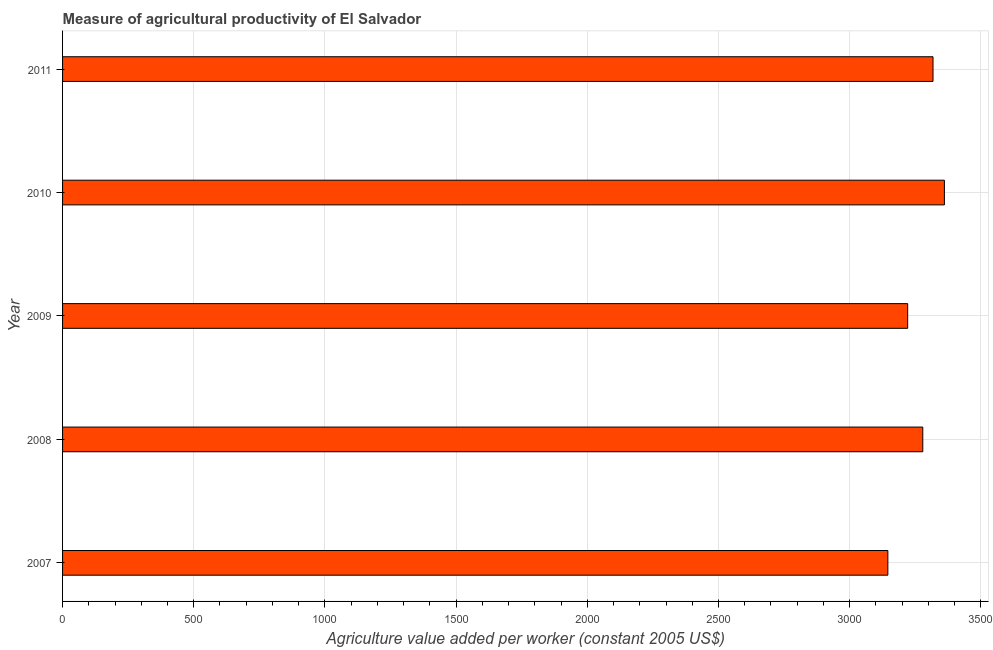What is the title of the graph?
Offer a terse response. Measure of agricultural productivity of El Salvador. What is the label or title of the X-axis?
Your answer should be compact. Agriculture value added per worker (constant 2005 US$). What is the agriculture value added per worker in 2010?
Provide a short and direct response. 3361.13. Across all years, what is the maximum agriculture value added per worker?
Provide a succinct answer. 3361.13. Across all years, what is the minimum agriculture value added per worker?
Your answer should be very brief. 3145.65. What is the sum of the agriculture value added per worker?
Make the answer very short. 1.63e+04. What is the difference between the agriculture value added per worker in 2007 and 2009?
Your response must be concise. -75.48. What is the average agriculture value added per worker per year?
Offer a very short reply. 3264.87. What is the median agriculture value added per worker?
Offer a very short reply. 3278.72. In how many years, is the agriculture value added per worker greater than 300 US$?
Provide a succinct answer. 5. Do a majority of the years between 2008 and 2007 (inclusive) have agriculture value added per worker greater than 300 US$?
Provide a succinct answer. No. What is the ratio of the agriculture value added per worker in 2009 to that in 2011?
Provide a succinct answer. 0.97. Is the agriculture value added per worker in 2010 less than that in 2011?
Ensure brevity in your answer.  No. Is the difference between the agriculture value added per worker in 2007 and 2008 greater than the difference between any two years?
Ensure brevity in your answer.  No. What is the difference between the highest and the second highest agriculture value added per worker?
Provide a succinct answer. 43.4. Is the sum of the agriculture value added per worker in 2007 and 2009 greater than the maximum agriculture value added per worker across all years?
Your answer should be very brief. Yes. What is the difference between the highest and the lowest agriculture value added per worker?
Give a very brief answer. 215.49. How many years are there in the graph?
Your response must be concise. 5. What is the difference between two consecutive major ticks on the X-axis?
Your answer should be very brief. 500. Are the values on the major ticks of X-axis written in scientific E-notation?
Your answer should be very brief. No. What is the Agriculture value added per worker (constant 2005 US$) of 2007?
Provide a short and direct response. 3145.65. What is the Agriculture value added per worker (constant 2005 US$) in 2008?
Ensure brevity in your answer.  3278.72. What is the Agriculture value added per worker (constant 2005 US$) in 2009?
Offer a very short reply. 3221.13. What is the Agriculture value added per worker (constant 2005 US$) in 2010?
Your response must be concise. 3361.13. What is the Agriculture value added per worker (constant 2005 US$) in 2011?
Provide a succinct answer. 3317.74. What is the difference between the Agriculture value added per worker (constant 2005 US$) in 2007 and 2008?
Offer a very short reply. -133.07. What is the difference between the Agriculture value added per worker (constant 2005 US$) in 2007 and 2009?
Your answer should be compact. -75.48. What is the difference between the Agriculture value added per worker (constant 2005 US$) in 2007 and 2010?
Keep it short and to the point. -215.49. What is the difference between the Agriculture value added per worker (constant 2005 US$) in 2007 and 2011?
Offer a very short reply. -172.09. What is the difference between the Agriculture value added per worker (constant 2005 US$) in 2008 and 2009?
Offer a very short reply. 57.59. What is the difference between the Agriculture value added per worker (constant 2005 US$) in 2008 and 2010?
Your response must be concise. -82.41. What is the difference between the Agriculture value added per worker (constant 2005 US$) in 2008 and 2011?
Your answer should be compact. -39.02. What is the difference between the Agriculture value added per worker (constant 2005 US$) in 2009 and 2010?
Ensure brevity in your answer.  -140.01. What is the difference between the Agriculture value added per worker (constant 2005 US$) in 2009 and 2011?
Your response must be concise. -96.61. What is the difference between the Agriculture value added per worker (constant 2005 US$) in 2010 and 2011?
Your answer should be very brief. 43.4. What is the ratio of the Agriculture value added per worker (constant 2005 US$) in 2007 to that in 2008?
Your answer should be compact. 0.96. What is the ratio of the Agriculture value added per worker (constant 2005 US$) in 2007 to that in 2010?
Your answer should be compact. 0.94. What is the ratio of the Agriculture value added per worker (constant 2005 US$) in 2007 to that in 2011?
Offer a terse response. 0.95. What is the ratio of the Agriculture value added per worker (constant 2005 US$) in 2008 to that in 2009?
Ensure brevity in your answer.  1.02. What is the ratio of the Agriculture value added per worker (constant 2005 US$) in 2008 to that in 2011?
Provide a short and direct response. 0.99. What is the ratio of the Agriculture value added per worker (constant 2005 US$) in 2009 to that in 2010?
Offer a very short reply. 0.96. What is the ratio of the Agriculture value added per worker (constant 2005 US$) in 2009 to that in 2011?
Offer a terse response. 0.97. What is the ratio of the Agriculture value added per worker (constant 2005 US$) in 2010 to that in 2011?
Keep it short and to the point. 1.01. 